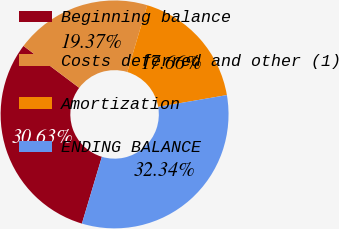Convert chart to OTSL. <chart><loc_0><loc_0><loc_500><loc_500><pie_chart><fcel>Beginning balance<fcel>Costs deferred and other (1)<fcel>Amortization<fcel>ENDING BALANCE<nl><fcel>30.63%<fcel>19.37%<fcel>17.66%<fcel>32.34%<nl></chart> 